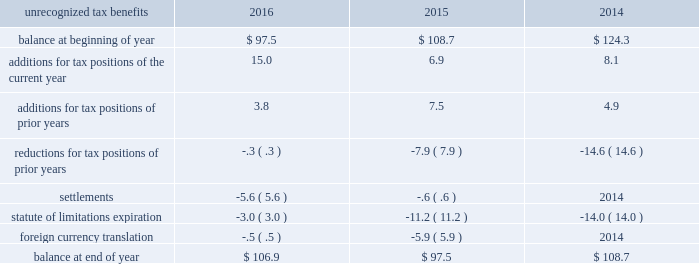The valuation allowance as of 30 september 2016 of $ 155.2 primarily related to the tax benefit on the federal capital loss carryforward of $ 48.0 , tax benefit of foreign loss carryforwards of $ 37.7 , and capital assets of $ 58.0 that were generated from the loss recorded on the exit from the energy-from-waste business in 2016 .
If events warrant the reversal of the valuation allowance , it would result in a reduction of tax expense .
We believe it is more likely than not that future earnings and reversal of deferred tax liabilities will be sufficient to utilize our deferred tax assets , net of existing valuation allowance , at 30 september 2016 .
The deferred tax liability associated with unremitted earnings of foreign entities decreased in part due to the dividend to repatriate cash from a foreign subsidiary in south korea .
This amount was also impacted by ongoing activity including earnings , dividend payments , tax credit adjustments , and currency translation impacting the undistributed earnings of our foreign subsidiaries and corporate joint ventures which are not considered to be indefinitely reinvested outside of the u.s .
We record u.s .
Income taxes on the undistributed earnings of our foreign subsidiaries and corporate joint ventures unless those earnings are indefinitely reinvested outside of the u.s .
These cumulative undistributed earnings that are considered to be indefinitely reinvested in foreign subsidiaries and corporate joint ventures are included in retained earnings on the consolidated balance sheets and amounted to $ 6300.9 as of 30 september 2016 .
An estimated $ 1467.8 in u.s .
Income and foreign withholding taxes would be due if these earnings were remitted as dividends after payment of all deferred taxes .
A reconciliation of the beginning and ending amount of the unrecognized tax benefits is as follows: .
At 30 september 2016 and 2015 , we had $ 106.9 and $ 97.5 of unrecognized tax benefits , excluding interest and penalties , of which $ 64.5 and $ 62.5 , respectively , would impact the effective tax rate if recognized .
Interest and penalties related to unrecognized tax benefits are recorded as a component of income tax expense and totaled $ 2.3 in 2016 , $ ( 1.8 ) in 2015 , and $ 1.2 in 2014 .
Our accrued balance for interest and penalties was $ 9.8 and $ 7.5 as of 30 september 2016 and 2015 , respectively. .
What is the increase observed in the accrued balance for interest and penalties during 2015 and 2016? 
Rationale: it is the 2016 value for the accrued balance for interest and penalties divided by the 2015's then subtracted 1 and turned into a percentage .
Computations: ((9.8 / 7.5) - 1)
Answer: 0.30667. 